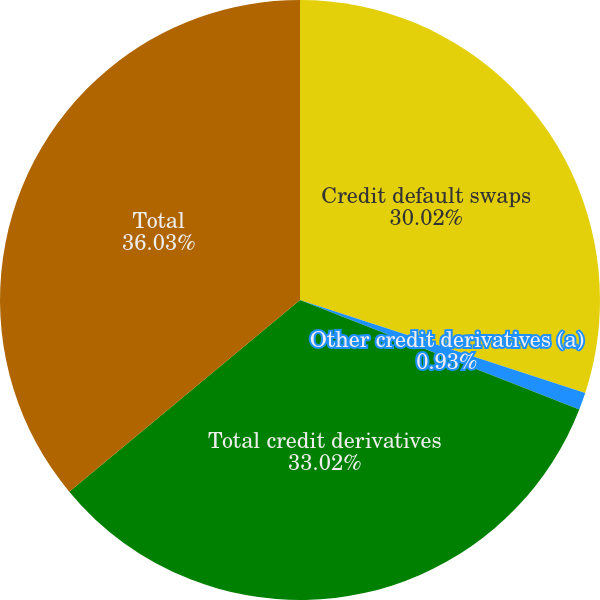Convert chart. <chart><loc_0><loc_0><loc_500><loc_500><pie_chart><fcel>Credit default swaps<fcel>Other credit derivatives (a)<fcel>Total credit derivatives<fcel>Total<nl><fcel>30.02%<fcel>0.93%<fcel>33.02%<fcel>36.03%<nl></chart> 